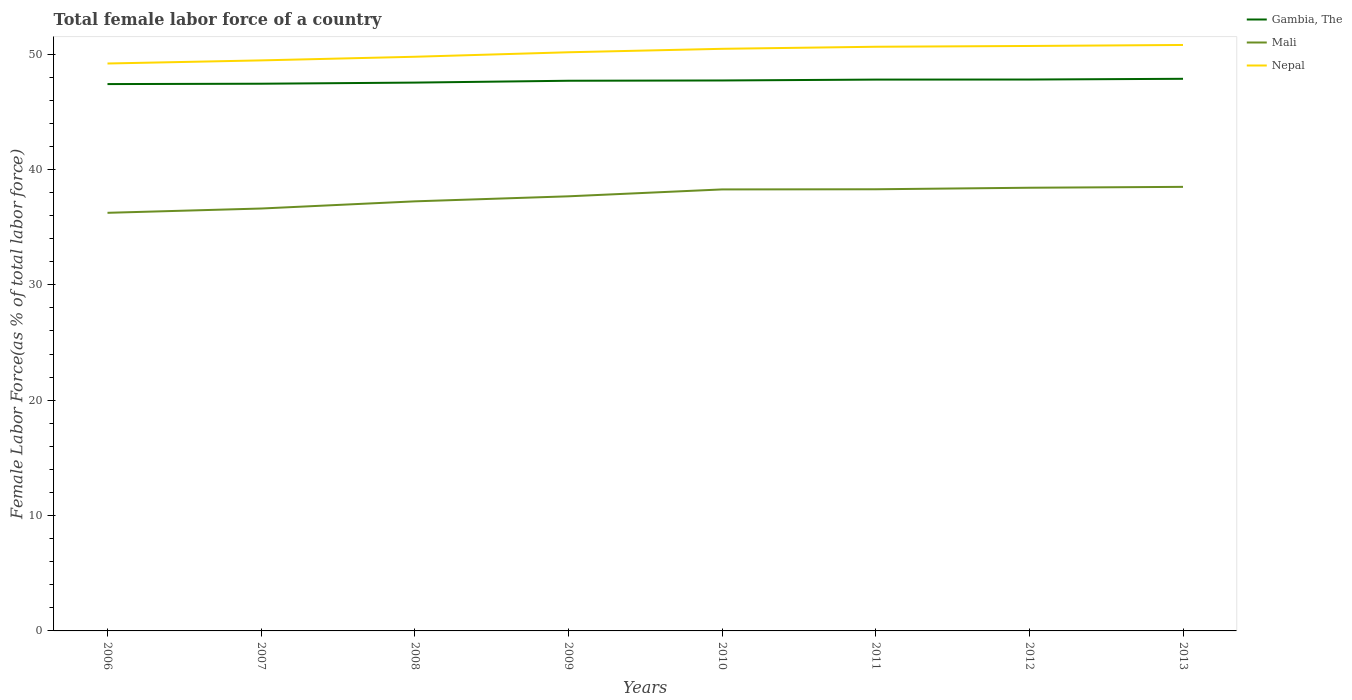Across all years, what is the maximum percentage of female labor force in Gambia, The?
Your response must be concise. 47.41. In which year was the percentage of female labor force in Mali maximum?
Your answer should be compact. 2006. What is the total percentage of female labor force in Mali in the graph?
Offer a terse response. -0.99. What is the difference between the highest and the second highest percentage of female labor force in Nepal?
Offer a very short reply. 1.61. What is the difference between the highest and the lowest percentage of female labor force in Gambia, The?
Give a very brief answer. 5. Is the percentage of female labor force in Gambia, The strictly greater than the percentage of female labor force in Nepal over the years?
Your response must be concise. Yes. How many lines are there?
Give a very brief answer. 3. How many years are there in the graph?
Keep it short and to the point. 8. What is the difference between two consecutive major ticks on the Y-axis?
Provide a succinct answer. 10. Are the values on the major ticks of Y-axis written in scientific E-notation?
Provide a short and direct response. No. Where does the legend appear in the graph?
Offer a terse response. Top right. What is the title of the graph?
Keep it short and to the point. Total female labor force of a country. Does "Yemen, Rep." appear as one of the legend labels in the graph?
Give a very brief answer. No. What is the label or title of the X-axis?
Make the answer very short. Years. What is the label or title of the Y-axis?
Give a very brief answer. Female Labor Force(as % of total labor force). What is the Female Labor Force(as % of total labor force) in Gambia, The in 2006?
Your answer should be compact. 47.41. What is the Female Labor Force(as % of total labor force) in Mali in 2006?
Give a very brief answer. 36.25. What is the Female Labor Force(as % of total labor force) in Nepal in 2006?
Make the answer very short. 49.19. What is the Female Labor Force(as % of total labor force) of Gambia, The in 2007?
Make the answer very short. 47.44. What is the Female Labor Force(as % of total labor force) in Mali in 2007?
Make the answer very short. 36.62. What is the Female Labor Force(as % of total labor force) of Nepal in 2007?
Your answer should be very brief. 49.46. What is the Female Labor Force(as % of total labor force) in Gambia, The in 2008?
Make the answer very short. 47.53. What is the Female Labor Force(as % of total labor force) of Mali in 2008?
Your answer should be very brief. 37.24. What is the Female Labor Force(as % of total labor force) of Nepal in 2008?
Provide a succinct answer. 49.77. What is the Female Labor Force(as % of total labor force) in Gambia, The in 2009?
Keep it short and to the point. 47.69. What is the Female Labor Force(as % of total labor force) in Mali in 2009?
Give a very brief answer. 37.68. What is the Female Labor Force(as % of total labor force) in Nepal in 2009?
Ensure brevity in your answer.  50.16. What is the Female Labor Force(as % of total labor force) in Gambia, The in 2010?
Your response must be concise. 47.72. What is the Female Labor Force(as % of total labor force) of Mali in 2010?
Your response must be concise. 38.27. What is the Female Labor Force(as % of total labor force) in Nepal in 2010?
Your response must be concise. 50.46. What is the Female Labor Force(as % of total labor force) of Gambia, The in 2011?
Make the answer very short. 47.79. What is the Female Labor Force(as % of total labor force) in Mali in 2011?
Offer a very short reply. 38.29. What is the Female Labor Force(as % of total labor force) of Nepal in 2011?
Keep it short and to the point. 50.64. What is the Female Labor Force(as % of total labor force) in Gambia, The in 2012?
Provide a succinct answer. 47.8. What is the Female Labor Force(as % of total labor force) in Mali in 2012?
Provide a short and direct response. 38.42. What is the Female Labor Force(as % of total labor force) in Nepal in 2012?
Your response must be concise. 50.71. What is the Female Labor Force(as % of total labor force) in Gambia, The in 2013?
Give a very brief answer. 47.86. What is the Female Labor Force(as % of total labor force) of Mali in 2013?
Ensure brevity in your answer.  38.5. What is the Female Labor Force(as % of total labor force) of Nepal in 2013?
Make the answer very short. 50.8. Across all years, what is the maximum Female Labor Force(as % of total labor force) of Gambia, The?
Make the answer very short. 47.86. Across all years, what is the maximum Female Labor Force(as % of total labor force) in Mali?
Offer a terse response. 38.5. Across all years, what is the maximum Female Labor Force(as % of total labor force) of Nepal?
Give a very brief answer. 50.8. Across all years, what is the minimum Female Labor Force(as % of total labor force) in Gambia, The?
Provide a succinct answer. 47.41. Across all years, what is the minimum Female Labor Force(as % of total labor force) of Mali?
Make the answer very short. 36.25. Across all years, what is the minimum Female Labor Force(as % of total labor force) of Nepal?
Offer a terse response. 49.19. What is the total Female Labor Force(as % of total labor force) of Gambia, The in the graph?
Offer a very short reply. 381.24. What is the total Female Labor Force(as % of total labor force) of Mali in the graph?
Give a very brief answer. 301.25. What is the total Female Labor Force(as % of total labor force) in Nepal in the graph?
Offer a terse response. 401.19. What is the difference between the Female Labor Force(as % of total labor force) of Gambia, The in 2006 and that in 2007?
Your response must be concise. -0.03. What is the difference between the Female Labor Force(as % of total labor force) in Mali in 2006 and that in 2007?
Give a very brief answer. -0.37. What is the difference between the Female Labor Force(as % of total labor force) in Nepal in 2006 and that in 2007?
Keep it short and to the point. -0.27. What is the difference between the Female Labor Force(as % of total labor force) in Gambia, The in 2006 and that in 2008?
Your answer should be compact. -0.13. What is the difference between the Female Labor Force(as % of total labor force) in Mali in 2006 and that in 2008?
Keep it short and to the point. -0.99. What is the difference between the Female Labor Force(as % of total labor force) of Nepal in 2006 and that in 2008?
Offer a terse response. -0.58. What is the difference between the Female Labor Force(as % of total labor force) of Gambia, The in 2006 and that in 2009?
Make the answer very short. -0.29. What is the difference between the Female Labor Force(as % of total labor force) in Mali in 2006 and that in 2009?
Make the answer very short. -1.43. What is the difference between the Female Labor Force(as % of total labor force) in Nepal in 2006 and that in 2009?
Your answer should be compact. -0.97. What is the difference between the Female Labor Force(as % of total labor force) of Gambia, The in 2006 and that in 2010?
Ensure brevity in your answer.  -0.31. What is the difference between the Female Labor Force(as % of total labor force) of Mali in 2006 and that in 2010?
Offer a very short reply. -2.03. What is the difference between the Female Labor Force(as % of total labor force) in Nepal in 2006 and that in 2010?
Ensure brevity in your answer.  -1.27. What is the difference between the Female Labor Force(as % of total labor force) in Gambia, The in 2006 and that in 2011?
Make the answer very short. -0.39. What is the difference between the Female Labor Force(as % of total labor force) in Mali in 2006 and that in 2011?
Your response must be concise. -2.04. What is the difference between the Female Labor Force(as % of total labor force) of Nepal in 2006 and that in 2011?
Your answer should be compact. -1.45. What is the difference between the Female Labor Force(as % of total labor force) of Gambia, The in 2006 and that in 2012?
Give a very brief answer. -0.39. What is the difference between the Female Labor Force(as % of total labor force) in Mali in 2006 and that in 2012?
Provide a succinct answer. -2.17. What is the difference between the Female Labor Force(as % of total labor force) in Nepal in 2006 and that in 2012?
Provide a short and direct response. -1.52. What is the difference between the Female Labor Force(as % of total labor force) of Gambia, The in 2006 and that in 2013?
Provide a short and direct response. -0.46. What is the difference between the Female Labor Force(as % of total labor force) of Mali in 2006 and that in 2013?
Provide a succinct answer. -2.25. What is the difference between the Female Labor Force(as % of total labor force) of Nepal in 2006 and that in 2013?
Your answer should be very brief. -1.61. What is the difference between the Female Labor Force(as % of total labor force) in Gambia, The in 2007 and that in 2008?
Your answer should be compact. -0.1. What is the difference between the Female Labor Force(as % of total labor force) in Mali in 2007 and that in 2008?
Make the answer very short. -0.62. What is the difference between the Female Labor Force(as % of total labor force) in Nepal in 2007 and that in 2008?
Keep it short and to the point. -0.32. What is the difference between the Female Labor Force(as % of total labor force) of Gambia, The in 2007 and that in 2009?
Provide a succinct answer. -0.26. What is the difference between the Female Labor Force(as % of total labor force) of Mali in 2007 and that in 2009?
Offer a very short reply. -1.06. What is the difference between the Female Labor Force(as % of total labor force) of Nepal in 2007 and that in 2009?
Give a very brief answer. -0.71. What is the difference between the Female Labor Force(as % of total labor force) in Gambia, The in 2007 and that in 2010?
Offer a terse response. -0.28. What is the difference between the Female Labor Force(as % of total labor force) in Mali in 2007 and that in 2010?
Make the answer very short. -1.66. What is the difference between the Female Labor Force(as % of total labor force) of Nepal in 2007 and that in 2010?
Provide a succinct answer. -1. What is the difference between the Female Labor Force(as % of total labor force) of Gambia, The in 2007 and that in 2011?
Your response must be concise. -0.36. What is the difference between the Female Labor Force(as % of total labor force) in Mali in 2007 and that in 2011?
Your response must be concise. -1.67. What is the difference between the Female Labor Force(as % of total labor force) in Nepal in 2007 and that in 2011?
Your response must be concise. -1.18. What is the difference between the Female Labor Force(as % of total labor force) of Gambia, The in 2007 and that in 2012?
Keep it short and to the point. -0.36. What is the difference between the Female Labor Force(as % of total labor force) in Mali in 2007 and that in 2012?
Your answer should be compact. -1.8. What is the difference between the Female Labor Force(as % of total labor force) of Nepal in 2007 and that in 2012?
Keep it short and to the point. -1.25. What is the difference between the Female Labor Force(as % of total labor force) of Gambia, The in 2007 and that in 2013?
Keep it short and to the point. -0.43. What is the difference between the Female Labor Force(as % of total labor force) in Mali in 2007 and that in 2013?
Keep it short and to the point. -1.88. What is the difference between the Female Labor Force(as % of total labor force) in Nepal in 2007 and that in 2013?
Offer a very short reply. -1.34. What is the difference between the Female Labor Force(as % of total labor force) of Gambia, The in 2008 and that in 2009?
Provide a short and direct response. -0.16. What is the difference between the Female Labor Force(as % of total labor force) of Mali in 2008 and that in 2009?
Ensure brevity in your answer.  -0.44. What is the difference between the Female Labor Force(as % of total labor force) in Nepal in 2008 and that in 2009?
Your response must be concise. -0.39. What is the difference between the Female Labor Force(as % of total labor force) of Gambia, The in 2008 and that in 2010?
Provide a short and direct response. -0.18. What is the difference between the Female Labor Force(as % of total labor force) in Mali in 2008 and that in 2010?
Offer a terse response. -1.03. What is the difference between the Female Labor Force(as % of total labor force) of Nepal in 2008 and that in 2010?
Your answer should be very brief. -0.69. What is the difference between the Female Labor Force(as % of total labor force) of Gambia, The in 2008 and that in 2011?
Your response must be concise. -0.26. What is the difference between the Female Labor Force(as % of total labor force) in Mali in 2008 and that in 2011?
Your answer should be compact. -1.05. What is the difference between the Female Labor Force(as % of total labor force) in Nepal in 2008 and that in 2011?
Keep it short and to the point. -0.87. What is the difference between the Female Labor Force(as % of total labor force) in Gambia, The in 2008 and that in 2012?
Make the answer very short. -0.27. What is the difference between the Female Labor Force(as % of total labor force) of Mali in 2008 and that in 2012?
Your answer should be very brief. -1.18. What is the difference between the Female Labor Force(as % of total labor force) in Nepal in 2008 and that in 2012?
Your answer should be very brief. -0.94. What is the difference between the Female Labor Force(as % of total labor force) of Gambia, The in 2008 and that in 2013?
Give a very brief answer. -0.33. What is the difference between the Female Labor Force(as % of total labor force) in Mali in 2008 and that in 2013?
Make the answer very short. -1.26. What is the difference between the Female Labor Force(as % of total labor force) of Nepal in 2008 and that in 2013?
Make the answer very short. -1.02. What is the difference between the Female Labor Force(as % of total labor force) in Gambia, The in 2009 and that in 2010?
Provide a succinct answer. -0.02. What is the difference between the Female Labor Force(as % of total labor force) in Mali in 2009 and that in 2010?
Your response must be concise. -0.6. What is the difference between the Female Labor Force(as % of total labor force) in Nepal in 2009 and that in 2010?
Ensure brevity in your answer.  -0.3. What is the difference between the Female Labor Force(as % of total labor force) of Gambia, The in 2009 and that in 2011?
Provide a succinct answer. -0.1. What is the difference between the Female Labor Force(as % of total labor force) in Mali in 2009 and that in 2011?
Provide a short and direct response. -0.61. What is the difference between the Female Labor Force(as % of total labor force) of Nepal in 2009 and that in 2011?
Provide a short and direct response. -0.48. What is the difference between the Female Labor Force(as % of total labor force) in Gambia, The in 2009 and that in 2012?
Provide a succinct answer. -0.11. What is the difference between the Female Labor Force(as % of total labor force) in Mali in 2009 and that in 2012?
Ensure brevity in your answer.  -0.74. What is the difference between the Female Labor Force(as % of total labor force) in Nepal in 2009 and that in 2012?
Provide a short and direct response. -0.55. What is the difference between the Female Labor Force(as % of total labor force) of Gambia, The in 2009 and that in 2013?
Give a very brief answer. -0.17. What is the difference between the Female Labor Force(as % of total labor force) of Mali in 2009 and that in 2013?
Keep it short and to the point. -0.82. What is the difference between the Female Labor Force(as % of total labor force) in Nepal in 2009 and that in 2013?
Your answer should be compact. -0.63. What is the difference between the Female Labor Force(as % of total labor force) in Gambia, The in 2010 and that in 2011?
Your answer should be compact. -0.08. What is the difference between the Female Labor Force(as % of total labor force) of Mali in 2010 and that in 2011?
Make the answer very short. -0.01. What is the difference between the Female Labor Force(as % of total labor force) of Nepal in 2010 and that in 2011?
Offer a terse response. -0.18. What is the difference between the Female Labor Force(as % of total labor force) of Gambia, The in 2010 and that in 2012?
Keep it short and to the point. -0.08. What is the difference between the Female Labor Force(as % of total labor force) of Mali in 2010 and that in 2012?
Provide a succinct answer. -0.15. What is the difference between the Female Labor Force(as % of total labor force) of Nepal in 2010 and that in 2012?
Keep it short and to the point. -0.25. What is the difference between the Female Labor Force(as % of total labor force) in Gambia, The in 2010 and that in 2013?
Provide a short and direct response. -0.14. What is the difference between the Female Labor Force(as % of total labor force) of Mali in 2010 and that in 2013?
Your response must be concise. -0.22. What is the difference between the Female Labor Force(as % of total labor force) in Nepal in 2010 and that in 2013?
Keep it short and to the point. -0.33. What is the difference between the Female Labor Force(as % of total labor force) of Gambia, The in 2011 and that in 2012?
Offer a very short reply. -0.01. What is the difference between the Female Labor Force(as % of total labor force) of Mali in 2011 and that in 2012?
Offer a very short reply. -0.13. What is the difference between the Female Labor Force(as % of total labor force) in Nepal in 2011 and that in 2012?
Make the answer very short. -0.07. What is the difference between the Female Labor Force(as % of total labor force) of Gambia, The in 2011 and that in 2013?
Provide a short and direct response. -0.07. What is the difference between the Female Labor Force(as % of total labor force) in Mali in 2011 and that in 2013?
Your answer should be compact. -0.21. What is the difference between the Female Labor Force(as % of total labor force) of Nepal in 2011 and that in 2013?
Your answer should be compact. -0.16. What is the difference between the Female Labor Force(as % of total labor force) of Gambia, The in 2012 and that in 2013?
Your answer should be compact. -0.06. What is the difference between the Female Labor Force(as % of total labor force) of Mali in 2012 and that in 2013?
Your answer should be very brief. -0.08. What is the difference between the Female Labor Force(as % of total labor force) of Nepal in 2012 and that in 2013?
Keep it short and to the point. -0.09. What is the difference between the Female Labor Force(as % of total labor force) in Gambia, The in 2006 and the Female Labor Force(as % of total labor force) in Mali in 2007?
Keep it short and to the point. 10.79. What is the difference between the Female Labor Force(as % of total labor force) in Gambia, The in 2006 and the Female Labor Force(as % of total labor force) in Nepal in 2007?
Ensure brevity in your answer.  -2.05. What is the difference between the Female Labor Force(as % of total labor force) in Mali in 2006 and the Female Labor Force(as % of total labor force) in Nepal in 2007?
Make the answer very short. -13.21. What is the difference between the Female Labor Force(as % of total labor force) in Gambia, The in 2006 and the Female Labor Force(as % of total labor force) in Mali in 2008?
Ensure brevity in your answer.  10.17. What is the difference between the Female Labor Force(as % of total labor force) of Gambia, The in 2006 and the Female Labor Force(as % of total labor force) of Nepal in 2008?
Ensure brevity in your answer.  -2.37. What is the difference between the Female Labor Force(as % of total labor force) in Mali in 2006 and the Female Labor Force(as % of total labor force) in Nepal in 2008?
Provide a succinct answer. -13.53. What is the difference between the Female Labor Force(as % of total labor force) of Gambia, The in 2006 and the Female Labor Force(as % of total labor force) of Mali in 2009?
Your answer should be compact. 9.73. What is the difference between the Female Labor Force(as % of total labor force) of Gambia, The in 2006 and the Female Labor Force(as % of total labor force) of Nepal in 2009?
Your answer should be compact. -2.76. What is the difference between the Female Labor Force(as % of total labor force) of Mali in 2006 and the Female Labor Force(as % of total labor force) of Nepal in 2009?
Give a very brief answer. -13.92. What is the difference between the Female Labor Force(as % of total labor force) of Gambia, The in 2006 and the Female Labor Force(as % of total labor force) of Mali in 2010?
Keep it short and to the point. 9.13. What is the difference between the Female Labor Force(as % of total labor force) of Gambia, The in 2006 and the Female Labor Force(as % of total labor force) of Nepal in 2010?
Provide a short and direct response. -3.06. What is the difference between the Female Labor Force(as % of total labor force) of Mali in 2006 and the Female Labor Force(as % of total labor force) of Nepal in 2010?
Offer a terse response. -14.22. What is the difference between the Female Labor Force(as % of total labor force) in Gambia, The in 2006 and the Female Labor Force(as % of total labor force) in Mali in 2011?
Offer a very short reply. 9.12. What is the difference between the Female Labor Force(as % of total labor force) in Gambia, The in 2006 and the Female Labor Force(as % of total labor force) in Nepal in 2011?
Give a very brief answer. -3.23. What is the difference between the Female Labor Force(as % of total labor force) of Mali in 2006 and the Female Labor Force(as % of total labor force) of Nepal in 2011?
Offer a very short reply. -14.39. What is the difference between the Female Labor Force(as % of total labor force) in Gambia, The in 2006 and the Female Labor Force(as % of total labor force) in Mali in 2012?
Give a very brief answer. 8.99. What is the difference between the Female Labor Force(as % of total labor force) of Gambia, The in 2006 and the Female Labor Force(as % of total labor force) of Nepal in 2012?
Make the answer very short. -3.3. What is the difference between the Female Labor Force(as % of total labor force) in Mali in 2006 and the Female Labor Force(as % of total labor force) in Nepal in 2012?
Offer a very short reply. -14.46. What is the difference between the Female Labor Force(as % of total labor force) in Gambia, The in 2006 and the Female Labor Force(as % of total labor force) in Mali in 2013?
Offer a very short reply. 8.91. What is the difference between the Female Labor Force(as % of total labor force) in Gambia, The in 2006 and the Female Labor Force(as % of total labor force) in Nepal in 2013?
Offer a very short reply. -3.39. What is the difference between the Female Labor Force(as % of total labor force) in Mali in 2006 and the Female Labor Force(as % of total labor force) in Nepal in 2013?
Offer a very short reply. -14.55. What is the difference between the Female Labor Force(as % of total labor force) of Gambia, The in 2007 and the Female Labor Force(as % of total labor force) of Mali in 2008?
Ensure brevity in your answer.  10.2. What is the difference between the Female Labor Force(as % of total labor force) in Gambia, The in 2007 and the Female Labor Force(as % of total labor force) in Nepal in 2008?
Offer a very short reply. -2.34. What is the difference between the Female Labor Force(as % of total labor force) of Mali in 2007 and the Female Labor Force(as % of total labor force) of Nepal in 2008?
Provide a succinct answer. -13.16. What is the difference between the Female Labor Force(as % of total labor force) of Gambia, The in 2007 and the Female Labor Force(as % of total labor force) of Mali in 2009?
Give a very brief answer. 9.76. What is the difference between the Female Labor Force(as % of total labor force) of Gambia, The in 2007 and the Female Labor Force(as % of total labor force) of Nepal in 2009?
Keep it short and to the point. -2.73. What is the difference between the Female Labor Force(as % of total labor force) in Mali in 2007 and the Female Labor Force(as % of total labor force) in Nepal in 2009?
Keep it short and to the point. -13.55. What is the difference between the Female Labor Force(as % of total labor force) in Gambia, The in 2007 and the Female Labor Force(as % of total labor force) in Mali in 2010?
Provide a short and direct response. 9.16. What is the difference between the Female Labor Force(as % of total labor force) of Gambia, The in 2007 and the Female Labor Force(as % of total labor force) of Nepal in 2010?
Ensure brevity in your answer.  -3.03. What is the difference between the Female Labor Force(as % of total labor force) of Mali in 2007 and the Female Labor Force(as % of total labor force) of Nepal in 2010?
Your answer should be very brief. -13.84. What is the difference between the Female Labor Force(as % of total labor force) of Gambia, The in 2007 and the Female Labor Force(as % of total labor force) of Mali in 2011?
Offer a very short reply. 9.15. What is the difference between the Female Labor Force(as % of total labor force) of Gambia, The in 2007 and the Female Labor Force(as % of total labor force) of Nepal in 2011?
Offer a terse response. -3.2. What is the difference between the Female Labor Force(as % of total labor force) of Mali in 2007 and the Female Labor Force(as % of total labor force) of Nepal in 2011?
Provide a succinct answer. -14.02. What is the difference between the Female Labor Force(as % of total labor force) of Gambia, The in 2007 and the Female Labor Force(as % of total labor force) of Mali in 2012?
Offer a terse response. 9.02. What is the difference between the Female Labor Force(as % of total labor force) in Gambia, The in 2007 and the Female Labor Force(as % of total labor force) in Nepal in 2012?
Offer a very short reply. -3.27. What is the difference between the Female Labor Force(as % of total labor force) of Mali in 2007 and the Female Labor Force(as % of total labor force) of Nepal in 2012?
Your response must be concise. -14.09. What is the difference between the Female Labor Force(as % of total labor force) in Gambia, The in 2007 and the Female Labor Force(as % of total labor force) in Mali in 2013?
Your answer should be very brief. 8.94. What is the difference between the Female Labor Force(as % of total labor force) in Gambia, The in 2007 and the Female Labor Force(as % of total labor force) in Nepal in 2013?
Your response must be concise. -3.36. What is the difference between the Female Labor Force(as % of total labor force) of Mali in 2007 and the Female Labor Force(as % of total labor force) of Nepal in 2013?
Offer a very short reply. -14.18. What is the difference between the Female Labor Force(as % of total labor force) in Gambia, The in 2008 and the Female Labor Force(as % of total labor force) in Mali in 2009?
Offer a terse response. 9.86. What is the difference between the Female Labor Force(as % of total labor force) in Gambia, The in 2008 and the Female Labor Force(as % of total labor force) in Nepal in 2009?
Provide a succinct answer. -2.63. What is the difference between the Female Labor Force(as % of total labor force) in Mali in 2008 and the Female Labor Force(as % of total labor force) in Nepal in 2009?
Offer a very short reply. -12.92. What is the difference between the Female Labor Force(as % of total labor force) of Gambia, The in 2008 and the Female Labor Force(as % of total labor force) of Mali in 2010?
Provide a succinct answer. 9.26. What is the difference between the Female Labor Force(as % of total labor force) in Gambia, The in 2008 and the Female Labor Force(as % of total labor force) in Nepal in 2010?
Keep it short and to the point. -2.93. What is the difference between the Female Labor Force(as % of total labor force) in Mali in 2008 and the Female Labor Force(as % of total labor force) in Nepal in 2010?
Offer a very short reply. -13.22. What is the difference between the Female Labor Force(as % of total labor force) in Gambia, The in 2008 and the Female Labor Force(as % of total labor force) in Mali in 2011?
Provide a short and direct response. 9.25. What is the difference between the Female Labor Force(as % of total labor force) of Gambia, The in 2008 and the Female Labor Force(as % of total labor force) of Nepal in 2011?
Keep it short and to the point. -3.11. What is the difference between the Female Labor Force(as % of total labor force) in Mali in 2008 and the Female Labor Force(as % of total labor force) in Nepal in 2011?
Keep it short and to the point. -13.4. What is the difference between the Female Labor Force(as % of total labor force) of Gambia, The in 2008 and the Female Labor Force(as % of total labor force) of Mali in 2012?
Make the answer very short. 9.11. What is the difference between the Female Labor Force(as % of total labor force) in Gambia, The in 2008 and the Female Labor Force(as % of total labor force) in Nepal in 2012?
Offer a very short reply. -3.18. What is the difference between the Female Labor Force(as % of total labor force) in Mali in 2008 and the Female Labor Force(as % of total labor force) in Nepal in 2012?
Your answer should be compact. -13.47. What is the difference between the Female Labor Force(as % of total labor force) of Gambia, The in 2008 and the Female Labor Force(as % of total labor force) of Mali in 2013?
Offer a very short reply. 9.04. What is the difference between the Female Labor Force(as % of total labor force) in Gambia, The in 2008 and the Female Labor Force(as % of total labor force) in Nepal in 2013?
Provide a short and direct response. -3.26. What is the difference between the Female Labor Force(as % of total labor force) of Mali in 2008 and the Female Labor Force(as % of total labor force) of Nepal in 2013?
Give a very brief answer. -13.56. What is the difference between the Female Labor Force(as % of total labor force) in Gambia, The in 2009 and the Female Labor Force(as % of total labor force) in Mali in 2010?
Ensure brevity in your answer.  9.42. What is the difference between the Female Labor Force(as % of total labor force) in Gambia, The in 2009 and the Female Labor Force(as % of total labor force) in Nepal in 2010?
Give a very brief answer. -2.77. What is the difference between the Female Labor Force(as % of total labor force) in Mali in 2009 and the Female Labor Force(as % of total labor force) in Nepal in 2010?
Your response must be concise. -12.79. What is the difference between the Female Labor Force(as % of total labor force) of Gambia, The in 2009 and the Female Labor Force(as % of total labor force) of Mali in 2011?
Your answer should be compact. 9.41. What is the difference between the Female Labor Force(as % of total labor force) in Gambia, The in 2009 and the Female Labor Force(as % of total labor force) in Nepal in 2011?
Offer a very short reply. -2.95. What is the difference between the Female Labor Force(as % of total labor force) in Mali in 2009 and the Female Labor Force(as % of total labor force) in Nepal in 2011?
Your response must be concise. -12.96. What is the difference between the Female Labor Force(as % of total labor force) in Gambia, The in 2009 and the Female Labor Force(as % of total labor force) in Mali in 2012?
Ensure brevity in your answer.  9.27. What is the difference between the Female Labor Force(as % of total labor force) of Gambia, The in 2009 and the Female Labor Force(as % of total labor force) of Nepal in 2012?
Your response must be concise. -3.02. What is the difference between the Female Labor Force(as % of total labor force) in Mali in 2009 and the Female Labor Force(as % of total labor force) in Nepal in 2012?
Give a very brief answer. -13.03. What is the difference between the Female Labor Force(as % of total labor force) of Gambia, The in 2009 and the Female Labor Force(as % of total labor force) of Mali in 2013?
Ensure brevity in your answer.  9.2. What is the difference between the Female Labor Force(as % of total labor force) in Gambia, The in 2009 and the Female Labor Force(as % of total labor force) in Nepal in 2013?
Offer a terse response. -3.1. What is the difference between the Female Labor Force(as % of total labor force) of Mali in 2009 and the Female Labor Force(as % of total labor force) of Nepal in 2013?
Offer a terse response. -13.12. What is the difference between the Female Labor Force(as % of total labor force) of Gambia, The in 2010 and the Female Labor Force(as % of total labor force) of Mali in 2011?
Offer a terse response. 9.43. What is the difference between the Female Labor Force(as % of total labor force) of Gambia, The in 2010 and the Female Labor Force(as % of total labor force) of Nepal in 2011?
Offer a very short reply. -2.92. What is the difference between the Female Labor Force(as % of total labor force) of Mali in 2010 and the Female Labor Force(as % of total labor force) of Nepal in 2011?
Provide a short and direct response. -12.37. What is the difference between the Female Labor Force(as % of total labor force) in Gambia, The in 2010 and the Female Labor Force(as % of total labor force) in Mali in 2012?
Make the answer very short. 9.3. What is the difference between the Female Labor Force(as % of total labor force) in Gambia, The in 2010 and the Female Labor Force(as % of total labor force) in Nepal in 2012?
Give a very brief answer. -2.99. What is the difference between the Female Labor Force(as % of total labor force) of Mali in 2010 and the Female Labor Force(as % of total labor force) of Nepal in 2012?
Ensure brevity in your answer.  -12.44. What is the difference between the Female Labor Force(as % of total labor force) of Gambia, The in 2010 and the Female Labor Force(as % of total labor force) of Mali in 2013?
Ensure brevity in your answer.  9.22. What is the difference between the Female Labor Force(as % of total labor force) in Gambia, The in 2010 and the Female Labor Force(as % of total labor force) in Nepal in 2013?
Your response must be concise. -3.08. What is the difference between the Female Labor Force(as % of total labor force) in Mali in 2010 and the Female Labor Force(as % of total labor force) in Nepal in 2013?
Provide a succinct answer. -12.52. What is the difference between the Female Labor Force(as % of total labor force) of Gambia, The in 2011 and the Female Labor Force(as % of total labor force) of Mali in 2012?
Give a very brief answer. 9.37. What is the difference between the Female Labor Force(as % of total labor force) in Gambia, The in 2011 and the Female Labor Force(as % of total labor force) in Nepal in 2012?
Offer a very short reply. -2.92. What is the difference between the Female Labor Force(as % of total labor force) in Mali in 2011 and the Female Labor Force(as % of total labor force) in Nepal in 2012?
Your answer should be very brief. -12.42. What is the difference between the Female Labor Force(as % of total labor force) of Gambia, The in 2011 and the Female Labor Force(as % of total labor force) of Mali in 2013?
Provide a short and direct response. 9.3. What is the difference between the Female Labor Force(as % of total labor force) in Gambia, The in 2011 and the Female Labor Force(as % of total labor force) in Nepal in 2013?
Your answer should be compact. -3. What is the difference between the Female Labor Force(as % of total labor force) of Mali in 2011 and the Female Labor Force(as % of total labor force) of Nepal in 2013?
Provide a short and direct response. -12.51. What is the difference between the Female Labor Force(as % of total labor force) of Gambia, The in 2012 and the Female Labor Force(as % of total labor force) of Mali in 2013?
Keep it short and to the point. 9.3. What is the difference between the Female Labor Force(as % of total labor force) of Gambia, The in 2012 and the Female Labor Force(as % of total labor force) of Nepal in 2013?
Provide a succinct answer. -3. What is the difference between the Female Labor Force(as % of total labor force) in Mali in 2012 and the Female Labor Force(as % of total labor force) in Nepal in 2013?
Give a very brief answer. -12.38. What is the average Female Labor Force(as % of total labor force) in Gambia, The per year?
Provide a short and direct response. 47.66. What is the average Female Labor Force(as % of total labor force) of Mali per year?
Your answer should be very brief. 37.66. What is the average Female Labor Force(as % of total labor force) of Nepal per year?
Offer a terse response. 50.15. In the year 2006, what is the difference between the Female Labor Force(as % of total labor force) of Gambia, The and Female Labor Force(as % of total labor force) of Mali?
Offer a terse response. 11.16. In the year 2006, what is the difference between the Female Labor Force(as % of total labor force) of Gambia, The and Female Labor Force(as % of total labor force) of Nepal?
Provide a succinct answer. -1.78. In the year 2006, what is the difference between the Female Labor Force(as % of total labor force) in Mali and Female Labor Force(as % of total labor force) in Nepal?
Provide a short and direct response. -12.94. In the year 2007, what is the difference between the Female Labor Force(as % of total labor force) of Gambia, The and Female Labor Force(as % of total labor force) of Mali?
Keep it short and to the point. 10.82. In the year 2007, what is the difference between the Female Labor Force(as % of total labor force) in Gambia, The and Female Labor Force(as % of total labor force) in Nepal?
Your answer should be very brief. -2.02. In the year 2007, what is the difference between the Female Labor Force(as % of total labor force) of Mali and Female Labor Force(as % of total labor force) of Nepal?
Offer a terse response. -12.84. In the year 2008, what is the difference between the Female Labor Force(as % of total labor force) in Gambia, The and Female Labor Force(as % of total labor force) in Mali?
Provide a short and direct response. 10.29. In the year 2008, what is the difference between the Female Labor Force(as % of total labor force) in Gambia, The and Female Labor Force(as % of total labor force) in Nepal?
Offer a very short reply. -2.24. In the year 2008, what is the difference between the Female Labor Force(as % of total labor force) of Mali and Female Labor Force(as % of total labor force) of Nepal?
Provide a short and direct response. -12.53. In the year 2009, what is the difference between the Female Labor Force(as % of total labor force) in Gambia, The and Female Labor Force(as % of total labor force) in Mali?
Your answer should be very brief. 10.02. In the year 2009, what is the difference between the Female Labor Force(as % of total labor force) of Gambia, The and Female Labor Force(as % of total labor force) of Nepal?
Make the answer very short. -2.47. In the year 2009, what is the difference between the Female Labor Force(as % of total labor force) of Mali and Female Labor Force(as % of total labor force) of Nepal?
Offer a very short reply. -12.49. In the year 2010, what is the difference between the Female Labor Force(as % of total labor force) of Gambia, The and Female Labor Force(as % of total labor force) of Mali?
Your response must be concise. 9.45. In the year 2010, what is the difference between the Female Labor Force(as % of total labor force) of Gambia, The and Female Labor Force(as % of total labor force) of Nepal?
Your response must be concise. -2.74. In the year 2010, what is the difference between the Female Labor Force(as % of total labor force) of Mali and Female Labor Force(as % of total labor force) of Nepal?
Keep it short and to the point. -12.19. In the year 2011, what is the difference between the Female Labor Force(as % of total labor force) in Gambia, The and Female Labor Force(as % of total labor force) in Mali?
Make the answer very short. 9.51. In the year 2011, what is the difference between the Female Labor Force(as % of total labor force) in Gambia, The and Female Labor Force(as % of total labor force) in Nepal?
Provide a short and direct response. -2.85. In the year 2011, what is the difference between the Female Labor Force(as % of total labor force) in Mali and Female Labor Force(as % of total labor force) in Nepal?
Your answer should be compact. -12.35. In the year 2012, what is the difference between the Female Labor Force(as % of total labor force) in Gambia, The and Female Labor Force(as % of total labor force) in Mali?
Ensure brevity in your answer.  9.38. In the year 2012, what is the difference between the Female Labor Force(as % of total labor force) of Gambia, The and Female Labor Force(as % of total labor force) of Nepal?
Your answer should be very brief. -2.91. In the year 2012, what is the difference between the Female Labor Force(as % of total labor force) of Mali and Female Labor Force(as % of total labor force) of Nepal?
Offer a terse response. -12.29. In the year 2013, what is the difference between the Female Labor Force(as % of total labor force) in Gambia, The and Female Labor Force(as % of total labor force) in Mali?
Make the answer very short. 9.37. In the year 2013, what is the difference between the Female Labor Force(as % of total labor force) of Gambia, The and Female Labor Force(as % of total labor force) of Nepal?
Offer a terse response. -2.93. In the year 2013, what is the difference between the Female Labor Force(as % of total labor force) in Mali and Female Labor Force(as % of total labor force) in Nepal?
Your answer should be very brief. -12.3. What is the ratio of the Female Labor Force(as % of total labor force) of Gambia, The in 2006 to that in 2008?
Ensure brevity in your answer.  1. What is the ratio of the Female Labor Force(as % of total labor force) in Mali in 2006 to that in 2008?
Your response must be concise. 0.97. What is the ratio of the Female Labor Force(as % of total labor force) of Gambia, The in 2006 to that in 2009?
Offer a very short reply. 0.99. What is the ratio of the Female Labor Force(as % of total labor force) in Mali in 2006 to that in 2009?
Your answer should be very brief. 0.96. What is the ratio of the Female Labor Force(as % of total labor force) of Nepal in 2006 to that in 2009?
Provide a short and direct response. 0.98. What is the ratio of the Female Labor Force(as % of total labor force) of Gambia, The in 2006 to that in 2010?
Ensure brevity in your answer.  0.99. What is the ratio of the Female Labor Force(as % of total labor force) of Mali in 2006 to that in 2010?
Offer a terse response. 0.95. What is the ratio of the Female Labor Force(as % of total labor force) of Nepal in 2006 to that in 2010?
Keep it short and to the point. 0.97. What is the ratio of the Female Labor Force(as % of total labor force) of Mali in 2006 to that in 2011?
Provide a succinct answer. 0.95. What is the ratio of the Female Labor Force(as % of total labor force) in Nepal in 2006 to that in 2011?
Offer a terse response. 0.97. What is the ratio of the Female Labor Force(as % of total labor force) of Mali in 2006 to that in 2012?
Make the answer very short. 0.94. What is the ratio of the Female Labor Force(as % of total labor force) in Nepal in 2006 to that in 2012?
Ensure brevity in your answer.  0.97. What is the ratio of the Female Labor Force(as % of total labor force) in Gambia, The in 2006 to that in 2013?
Your answer should be compact. 0.99. What is the ratio of the Female Labor Force(as % of total labor force) in Mali in 2006 to that in 2013?
Offer a very short reply. 0.94. What is the ratio of the Female Labor Force(as % of total labor force) in Nepal in 2006 to that in 2013?
Offer a very short reply. 0.97. What is the ratio of the Female Labor Force(as % of total labor force) of Gambia, The in 2007 to that in 2008?
Your response must be concise. 1. What is the ratio of the Female Labor Force(as % of total labor force) of Mali in 2007 to that in 2008?
Offer a terse response. 0.98. What is the ratio of the Female Labor Force(as % of total labor force) in Nepal in 2007 to that in 2008?
Your answer should be compact. 0.99. What is the ratio of the Female Labor Force(as % of total labor force) in Mali in 2007 to that in 2009?
Offer a very short reply. 0.97. What is the ratio of the Female Labor Force(as % of total labor force) in Nepal in 2007 to that in 2009?
Provide a short and direct response. 0.99. What is the ratio of the Female Labor Force(as % of total labor force) of Mali in 2007 to that in 2010?
Ensure brevity in your answer.  0.96. What is the ratio of the Female Labor Force(as % of total labor force) of Nepal in 2007 to that in 2010?
Ensure brevity in your answer.  0.98. What is the ratio of the Female Labor Force(as % of total labor force) in Gambia, The in 2007 to that in 2011?
Ensure brevity in your answer.  0.99. What is the ratio of the Female Labor Force(as % of total labor force) in Mali in 2007 to that in 2011?
Your answer should be compact. 0.96. What is the ratio of the Female Labor Force(as % of total labor force) in Nepal in 2007 to that in 2011?
Offer a very short reply. 0.98. What is the ratio of the Female Labor Force(as % of total labor force) of Mali in 2007 to that in 2012?
Ensure brevity in your answer.  0.95. What is the ratio of the Female Labor Force(as % of total labor force) of Nepal in 2007 to that in 2012?
Ensure brevity in your answer.  0.98. What is the ratio of the Female Labor Force(as % of total labor force) in Mali in 2007 to that in 2013?
Your response must be concise. 0.95. What is the ratio of the Female Labor Force(as % of total labor force) of Nepal in 2007 to that in 2013?
Keep it short and to the point. 0.97. What is the ratio of the Female Labor Force(as % of total labor force) of Mali in 2008 to that in 2009?
Offer a very short reply. 0.99. What is the ratio of the Female Labor Force(as % of total labor force) in Nepal in 2008 to that in 2009?
Make the answer very short. 0.99. What is the ratio of the Female Labor Force(as % of total labor force) of Nepal in 2008 to that in 2010?
Keep it short and to the point. 0.99. What is the ratio of the Female Labor Force(as % of total labor force) in Gambia, The in 2008 to that in 2011?
Your answer should be compact. 0.99. What is the ratio of the Female Labor Force(as % of total labor force) of Mali in 2008 to that in 2011?
Offer a very short reply. 0.97. What is the ratio of the Female Labor Force(as % of total labor force) in Nepal in 2008 to that in 2011?
Provide a short and direct response. 0.98. What is the ratio of the Female Labor Force(as % of total labor force) of Gambia, The in 2008 to that in 2012?
Ensure brevity in your answer.  0.99. What is the ratio of the Female Labor Force(as % of total labor force) in Mali in 2008 to that in 2012?
Ensure brevity in your answer.  0.97. What is the ratio of the Female Labor Force(as % of total labor force) of Nepal in 2008 to that in 2012?
Make the answer very short. 0.98. What is the ratio of the Female Labor Force(as % of total labor force) in Mali in 2008 to that in 2013?
Make the answer very short. 0.97. What is the ratio of the Female Labor Force(as % of total labor force) in Nepal in 2008 to that in 2013?
Offer a terse response. 0.98. What is the ratio of the Female Labor Force(as % of total labor force) in Gambia, The in 2009 to that in 2010?
Keep it short and to the point. 1. What is the ratio of the Female Labor Force(as % of total labor force) in Mali in 2009 to that in 2010?
Provide a succinct answer. 0.98. What is the ratio of the Female Labor Force(as % of total labor force) in Mali in 2009 to that in 2011?
Your response must be concise. 0.98. What is the ratio of the Female Labor Force(as % of total labor force) of Nepal in 2009 to that in 2011?
Offer a terse response. 0.99. What is the ratio of the Female Labor Force(as % of total labor force) in Mali in 2009 to that in 2012?
Provide a succinct answer. 0.98. What is the ratio of the Female Labor Force(as % of total labor force) in Gambia, The in 2009 to that in 2013?
Your response must be concise. 1. What is the ratio of the Female Labor Force(as % of total labor force) in Mali in 2009 to that in 2013?
Your answer should be very brief. 0.98. What is the ratio of the Female Labor Force(as % of total labor force) in Nepal in 2009 to that in 2013?
Your response must be concise. 0.99. What is the ratio of the Female Labor Force(as % of total labor force) in Nepal in 2010 to that in 2011?
Your answer should be compact. 1. What is the ratio of the Female Labor Force(as % of total labor force) in Gambia, The in 2010 to that in 2013?
Ensure brevity in your answer.  1. What is the ratio of the Female Labor Force(as % of total labor force) of Gambia, The in 2011 to that in 2012?
Offer a very short reply. 1. What is the ratio of the Female Labor Force(as % of total labor force) of Gambia, The in 2012 to that in 2013?
Your answer should be compact. 1. What is the ratio of the Female Labor Force(as % of total labor force) in Mali in 2012 to that in 2013?
Provide a succinct answer. 1. What is the difference between the highest and the second highest Female Labor Force(as % of total labor force) in Gambia, The?
Offer a very short reply. 0.06. What is the difference between the highest and the second highest Female Labor Force(as % of total labor force) in Mali?
Provide a succinct answer. 0.08. What is the difference between the highest and the second highest Female Labor Force(as % of total labor force) of Nepal?
Make the answer very short. 0.09. What is the difference between the highest and the lowest Female Labor Force(as % of total labor force) in Gambia, The?
Give a very brief answer. 0.46. What is the difference between the highest and the lowest Female Labor Force(as % of total labor force) in Mali?
Your answer should be very brief. 2.25. What is the difference between the highest and the lowest Female Labor Force(as % of total labor force) of Nepal?
Ensure brevity in your answer.  1.61. 